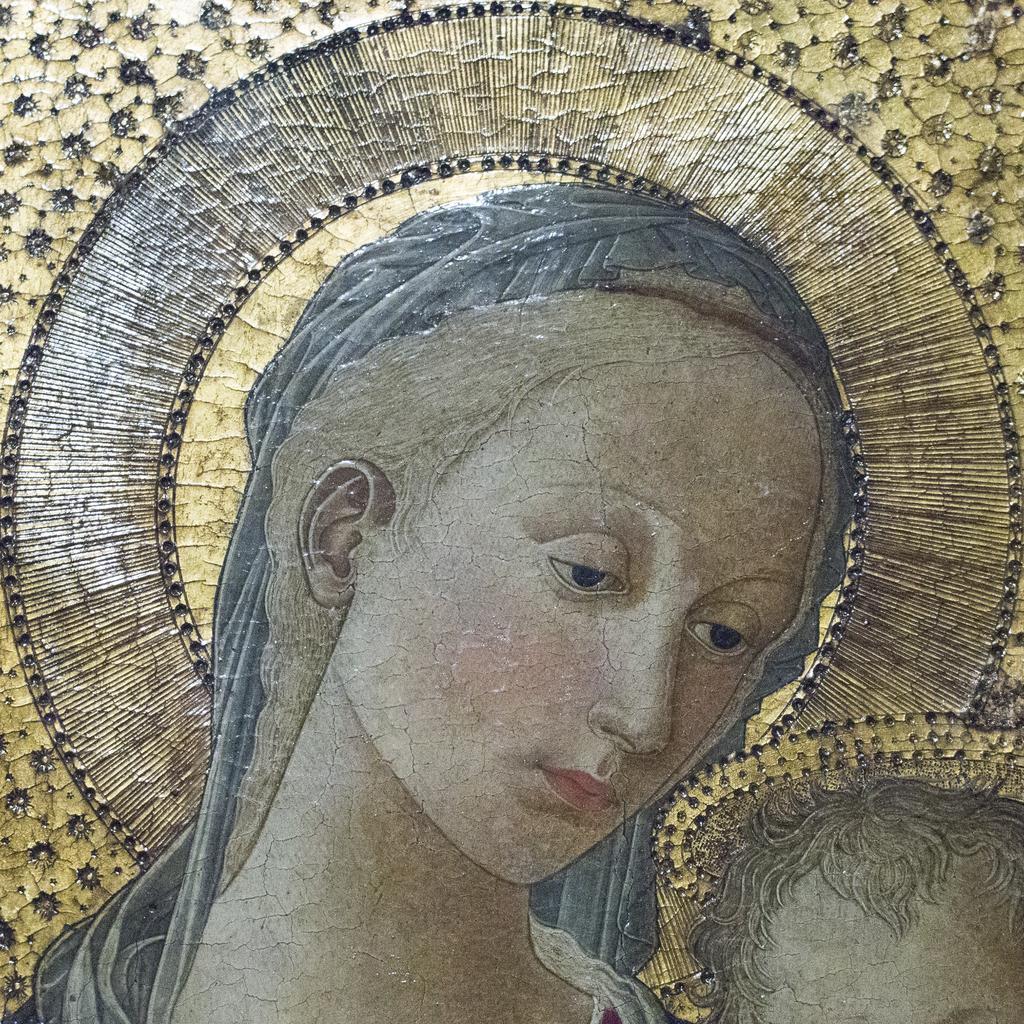Can you describe this image briefly? In this image I see the depiction of the woman and I see the design over here. 